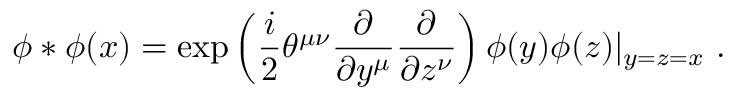Convert formula to latex. <formula><loc_0><loc_0><loc_500><loc_500>\phi * \phi ( x ) = \exp \left ( \frac { i } { 2 } \theta ^ { \mu \nu } \frac { \partial } { \partial y ^ { \mu } } \frac { \partial } { \partial z ^ { \nu } } \right ) \phi ( y ) \phi ( z ) | _ { y = z = x } .</formula> 